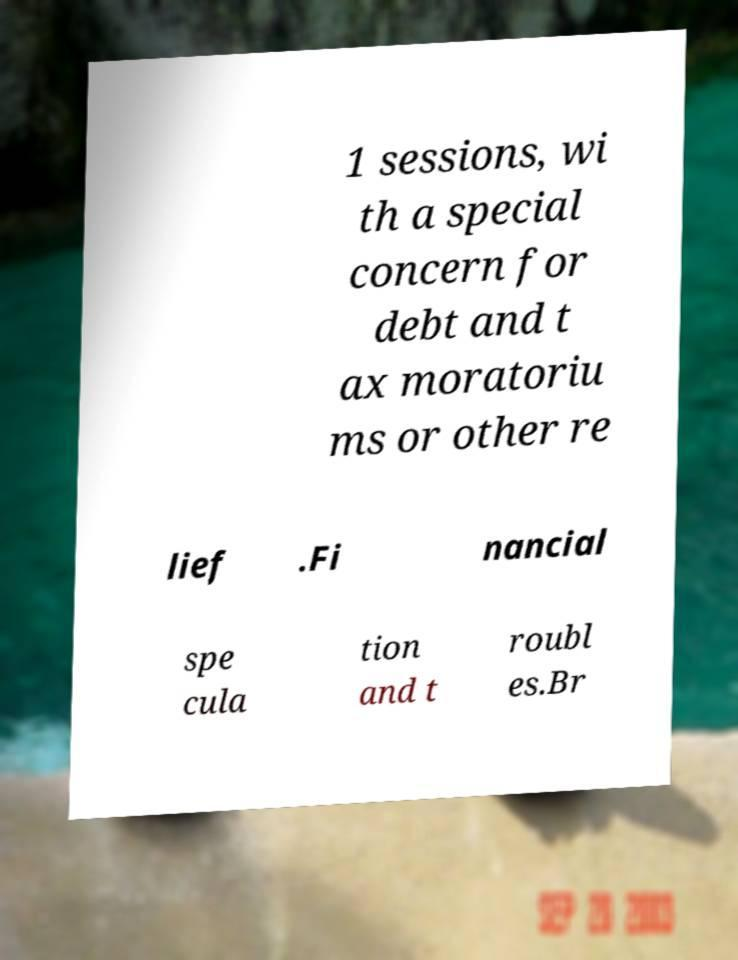What messages or text are displayed in this image? I need them in a readable, typed format. 1 sessions, wi th a special concern for debt and t ax moratoriu ms or other re lief .Fi nancial spe cula tion and t roubl es.Br 